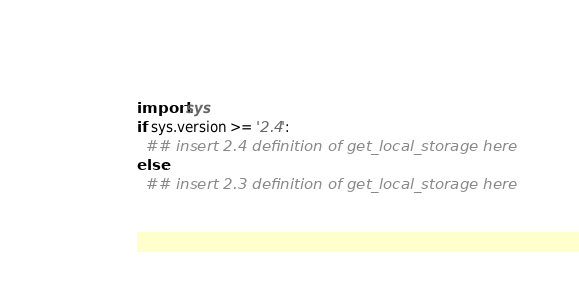Convert code to text. <code><loc_0><loc_0><loc_500><loc_500><_Python_>import sys
if sys.version >= '2.4':
  ## insert 2.4 definition of get_local_storage here
else:
  ## insert 2.3 definition of get_local_storage here
</code> 